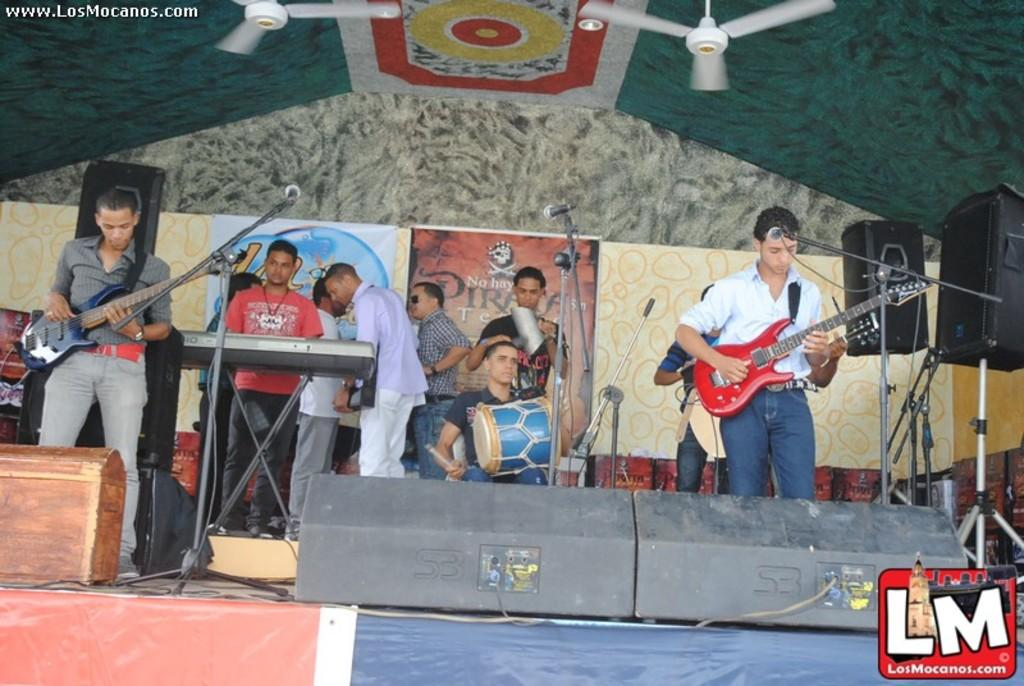What is happening in the image? There is a group of people in the image, and they are playing musical instruments. What are the people doing in the image? The people are playing musical instruments. What type of ghost can be seen playing a musical instrument in the image? There are no ghosts present in the image; it features a group of people playing musical instruments. 